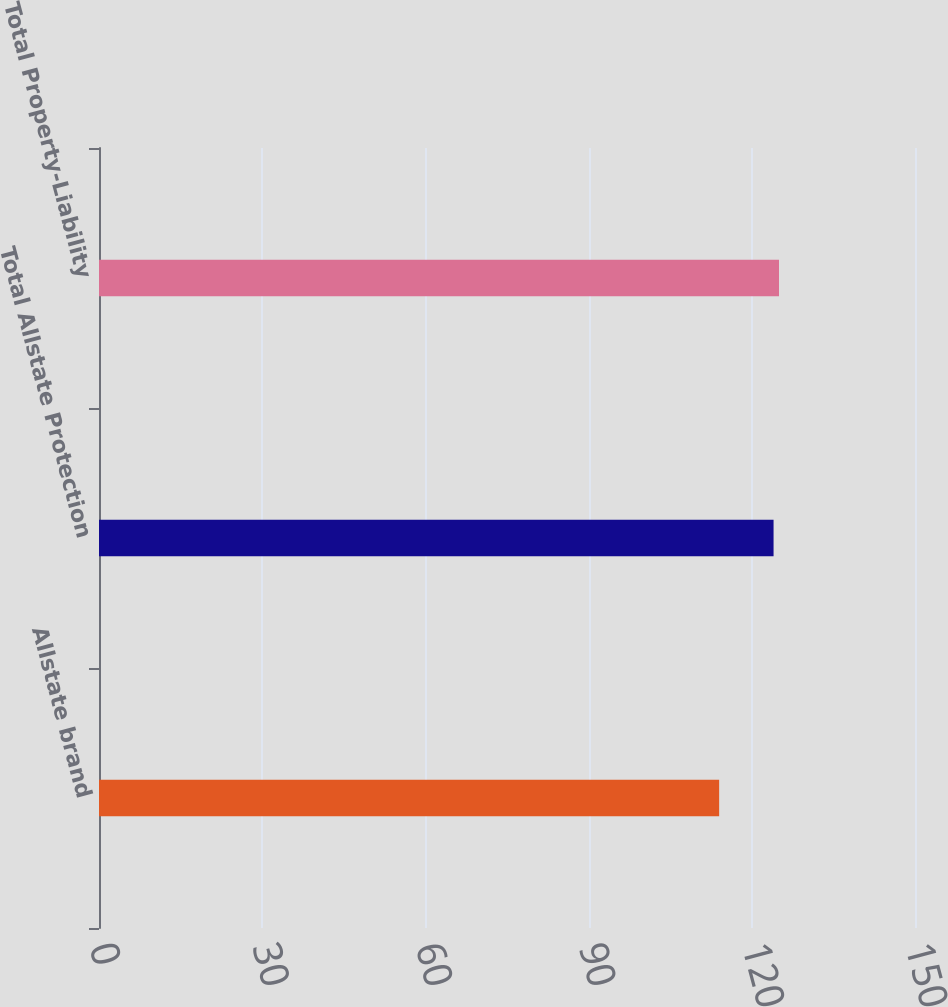Convert chart. <chart><loc_0><loc_0><loc_500><loc_500><bar_chart><fcel>Allstate brand<fcel>Total Allstate Protection<fcel>Total Property-Liability<nl><fcel>114<fcel>124<fcel>125<nl></chart> 